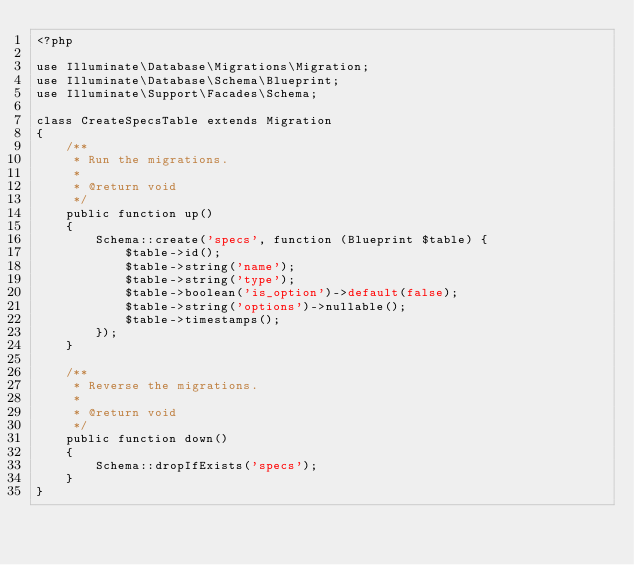Convert code to text. <code><loc_0><loc_0><loc_500><loc_500><_PHP_><?php

use Illuminate\Database\Migrations\Migration;
use Illuminate\Database\Schema\Blueprint;
use Illuminate\Support\Facades\Schema;

class CreateSpecsTable extends Migration
{
    /**
     * Run the migrations.
     *
     * @return void
     */
    public function up()
    {
        Schema::create('specs', function (Blueprint $table) {
            $table->id();
            $table->string('name');
            $table->string('type');
            $table->boolean('is_option')->default(false);
            $table->string('options')->nullable();
            $table->timestamps();
        });
    }

    /**
     * Reverse the migrations.
     *
     * @return void
     */
    public function down()
    {
        Schema::dropIfExists('specs');
    }
}
</code> 